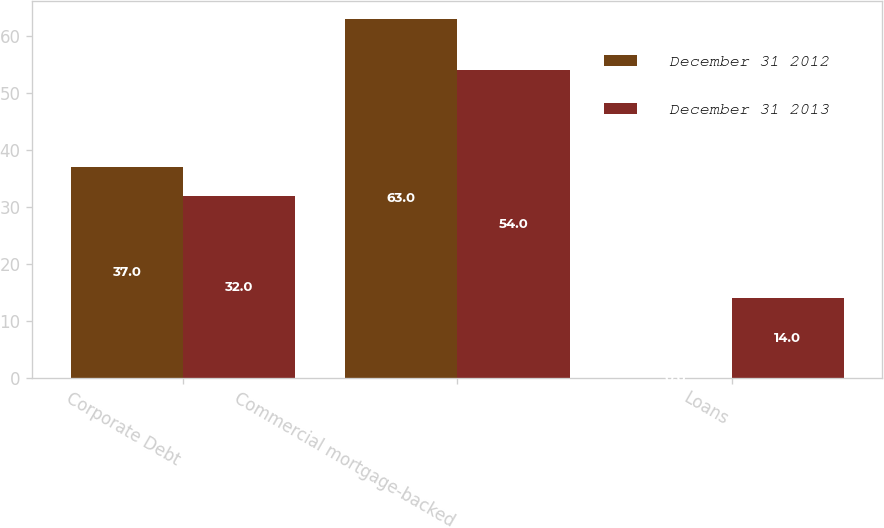<chart> <loc_0><loc_0><loc_500><loc_500><stacked_bar_chart><ecel><fcel>Corporate Debt<fcel>Commercial mortgage-backed<fcel>Loans<nl><fcel>December 31 2012<fcel>37<fcel>63<fcel>0<nl><fcel>December 31 2013<fcel>32<fcel>54<fcel>14<nl></chart> 